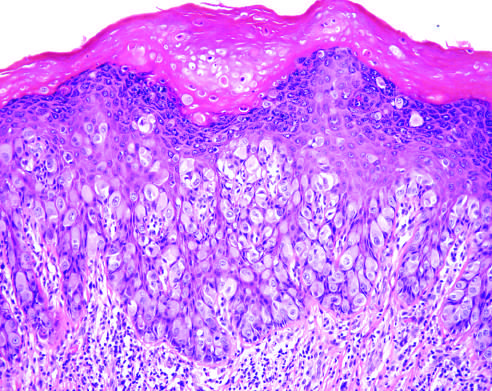re portal tracts and the periportal parenchyma seen infiltrating the epidermis?
Answer the question using a single word or phrase. No 